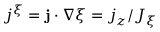<formula> <loc_0><loc_0><loc_500><loc_500>j ^ { \xi } = j \cdot \nabla \xi = j _ { z } / J _ { \xi }</formula> 